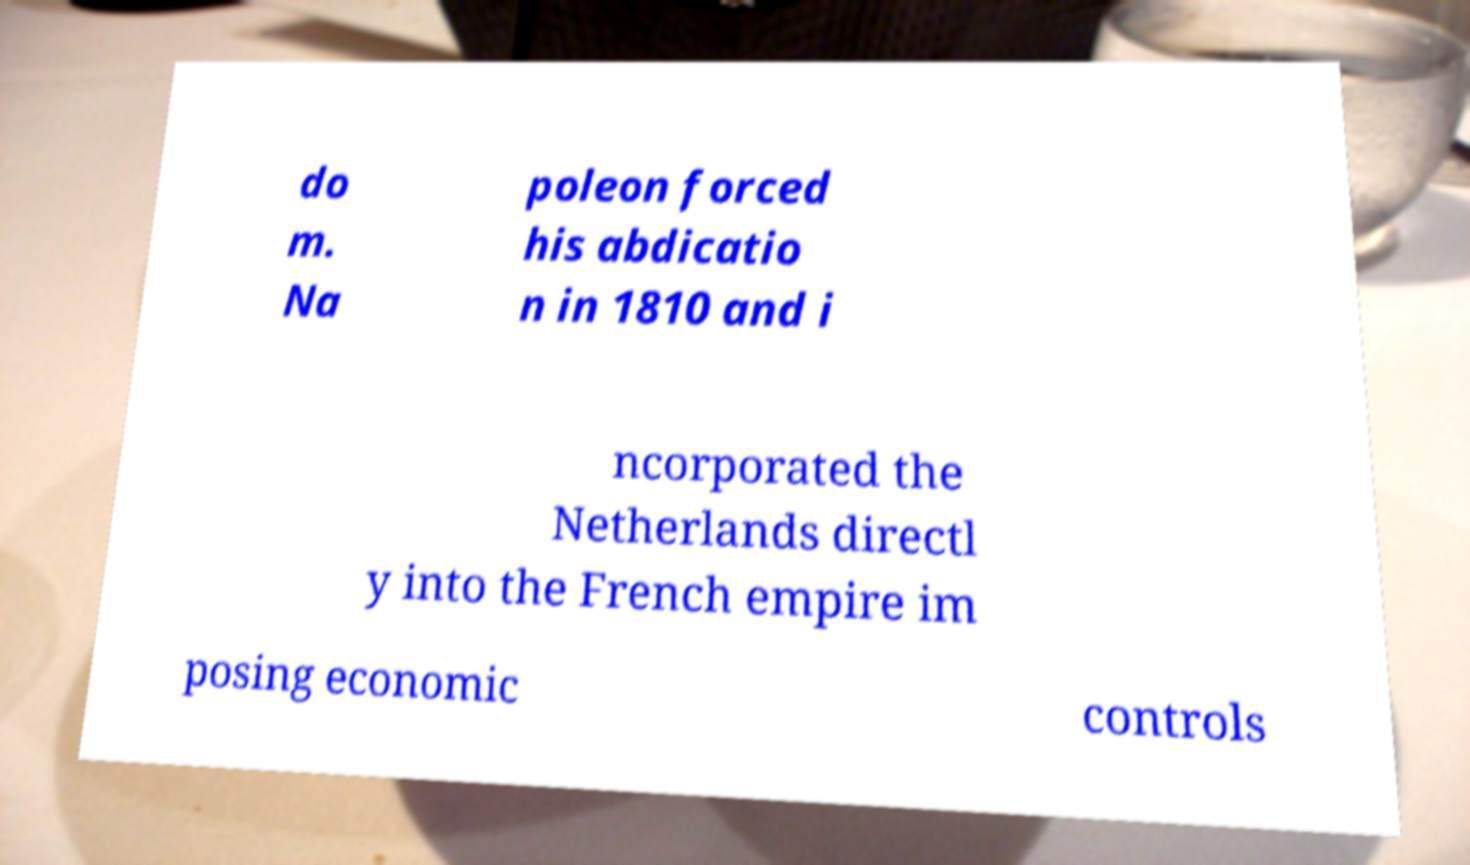Please read and relay the text visible in this image. What does it say? do m. Na poleon forced his abdicatio n in 1810 and i ncorporated the Netherlands directl y into the French empire im posing economic controls 